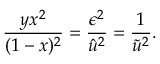Convert formula to latex. <formula><loc_0><loc_0><loc_500><loc_500>\frac { y x ^ { 2 } } { ( 1 - x ) ^ { 2 } } = \frac { \epsilon ^ { 2 } } { \hat { u } ^ { 2 } } = \frac { 1 } { \tilde { u } ^ { 2 } } .</formula> 